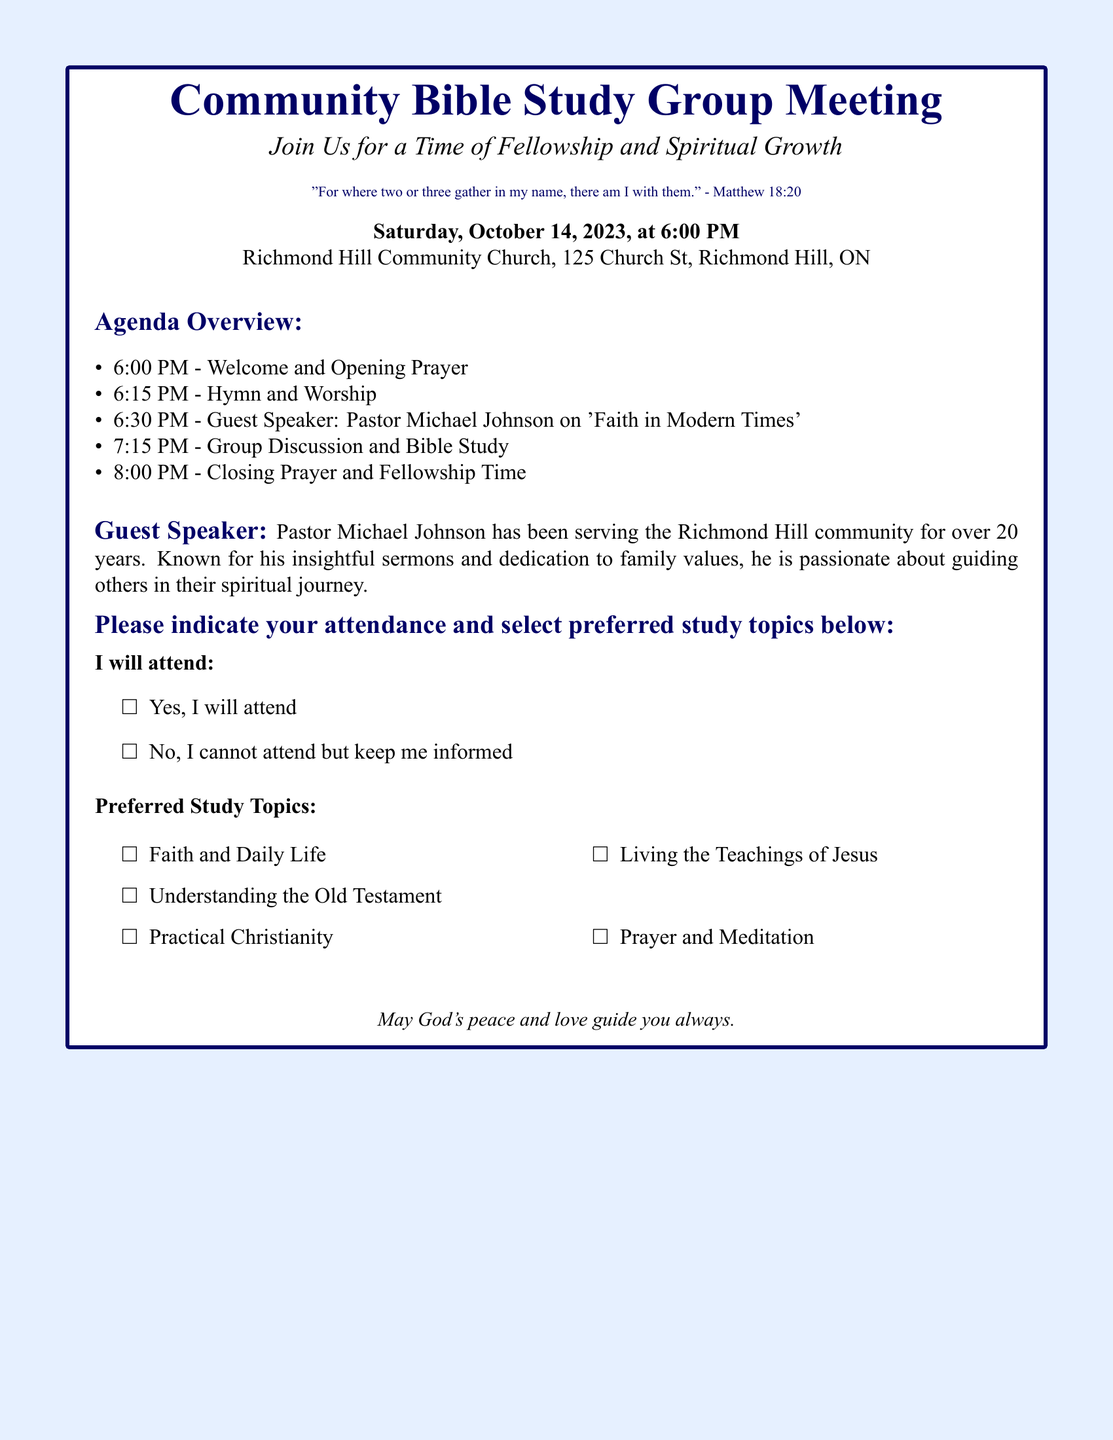What is the date of the meeting? The date of the meeting is specified in the document, which is Saturday, October 14, 2023.
Answer: Saturday, October 14, 2023 What time does the meeting start? The starting time is indicated in the agenda overview, which states the meeting begins at 6:00 PM.
Answer: 6:00 PM Who is the guest speaker? The guest speaker is mentioned in the speaker details section, who is Pastor Michael Johnson.
Answer: Pastor Michael Johnson What is the topic of the guest speaker's talk? The topic of the guest speaker's talk is listed in the document as 'Faith in Modern Times.'
Answer: Faith in Modern Times How many study topics can be selected? The number of study topics can be derived from the list provided, which contains five options for preferred study topics.
Answer: Five What is the purpose of the meeting? The purpose can be inferred from the introductory text, which emphasizes fellowship and spiritual growth.
Answer: Fellowship and spiritual growth What biblical verse is included in the document? The document contains a scripture verse, which is from Matthew 18:20.
Answer: "For where two or three gather in my name, there am I with them." What is the closing activity of the meeting? The closing activity is outlined in the agenda, indicating it as 'Closing Prayer and Fellowship Time.'
Answer: Closing Prayer and Fellowship Time 